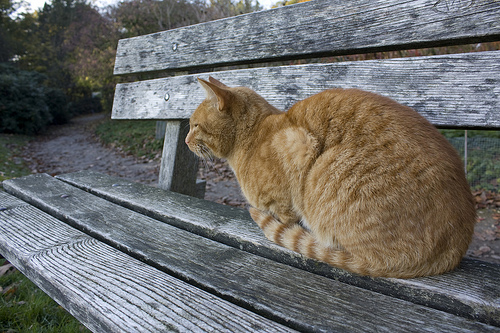Describe the weather and surroundings in the image. The weather appears to be sunny, with a clear sky overhead. The surroundings include a wooden bench situated in front of a dirt path. There is grass under the bench and greenery surrounding the path, providing a serene and natural setting. 